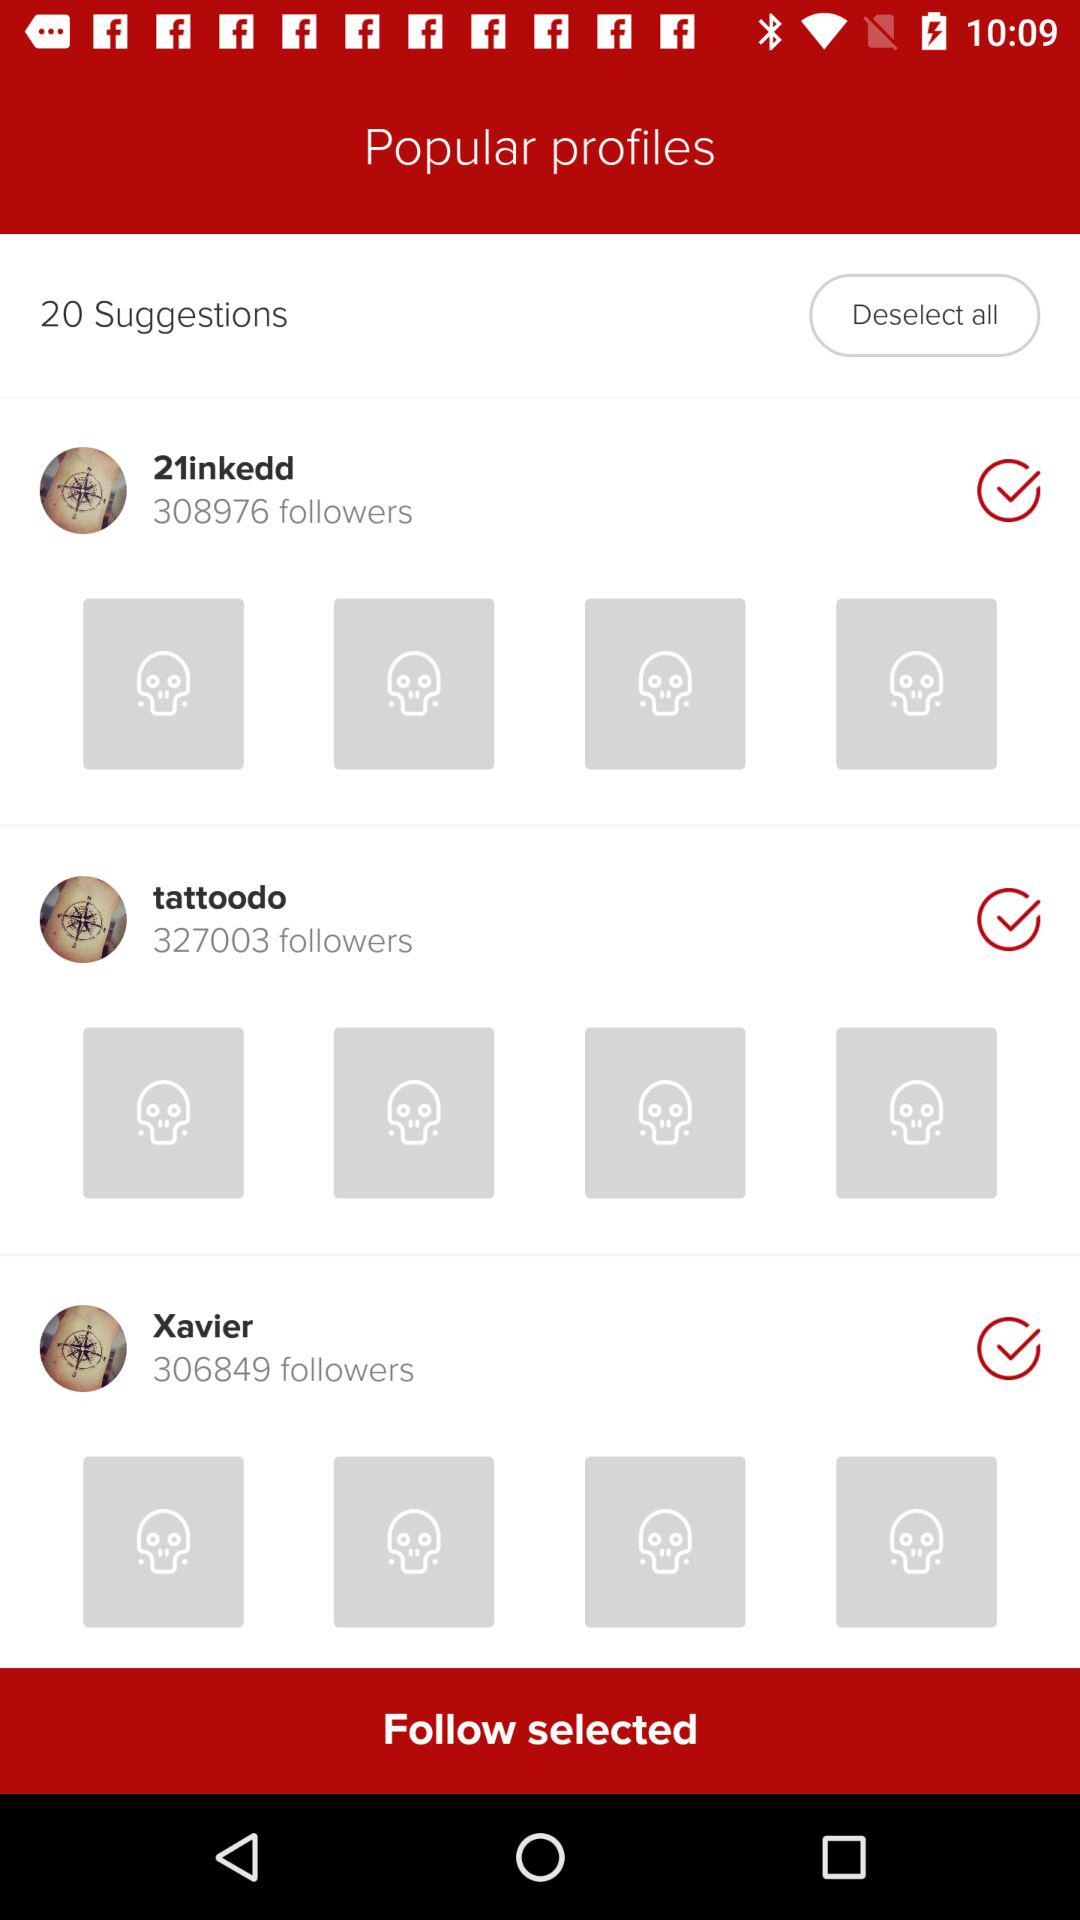How many followers does "21inkedd" have? "21inkedd" has 308976 followers. 